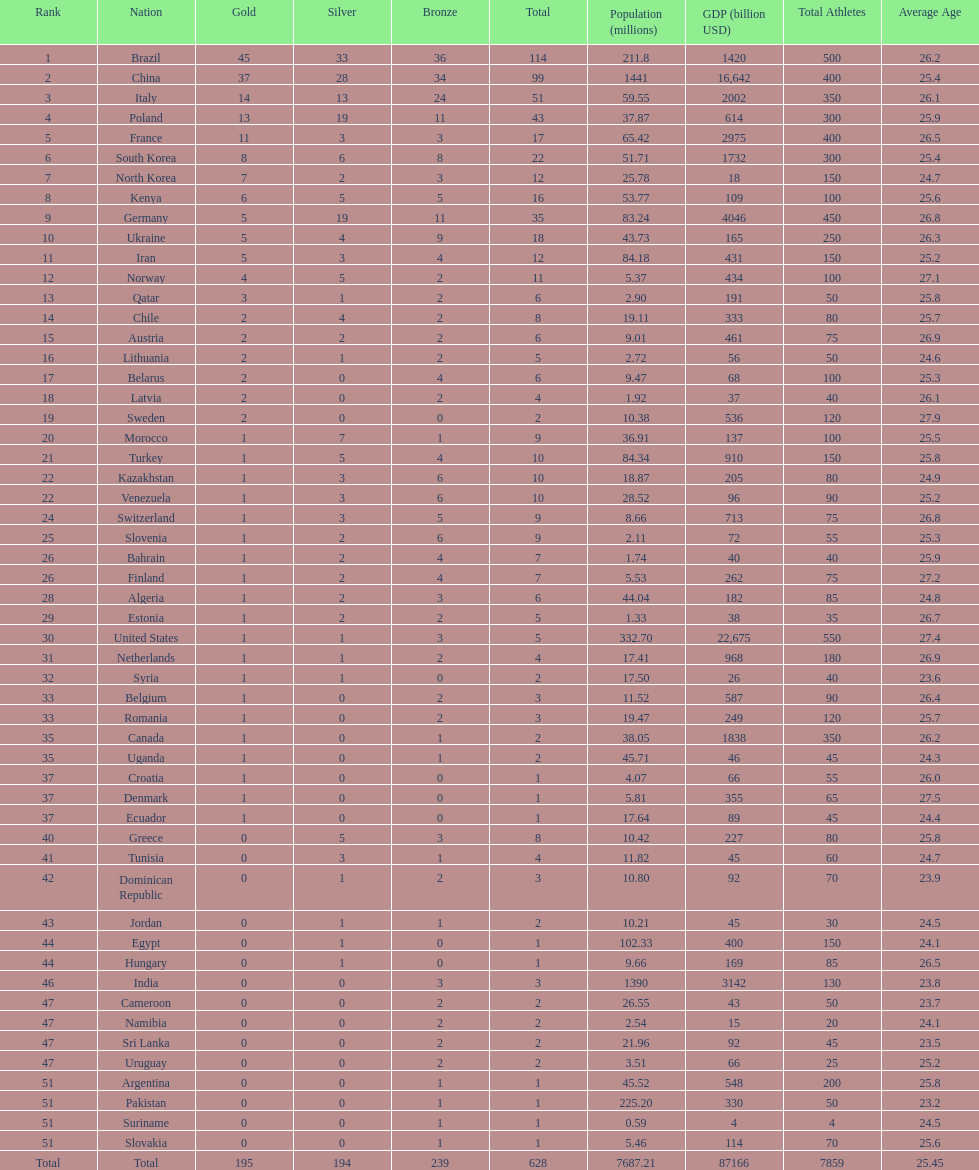South korea has how many more medals that north korea? 10. 